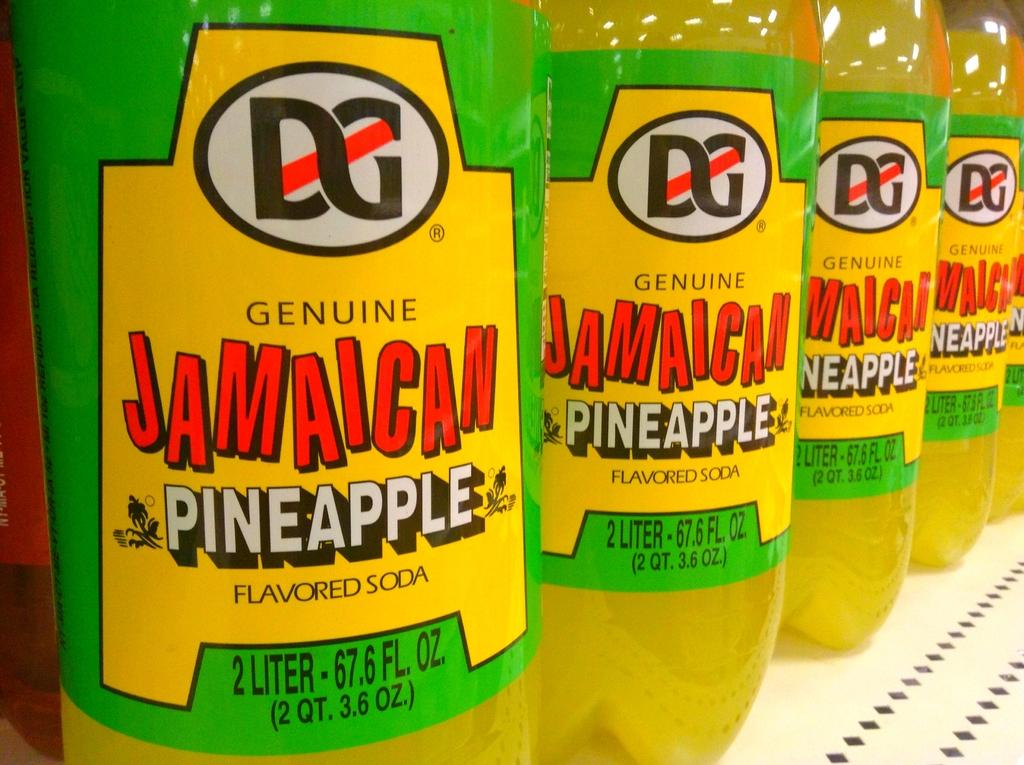Provide a one-sentence caption for the provided image. a Jamaican pineapple drink along with many others. 